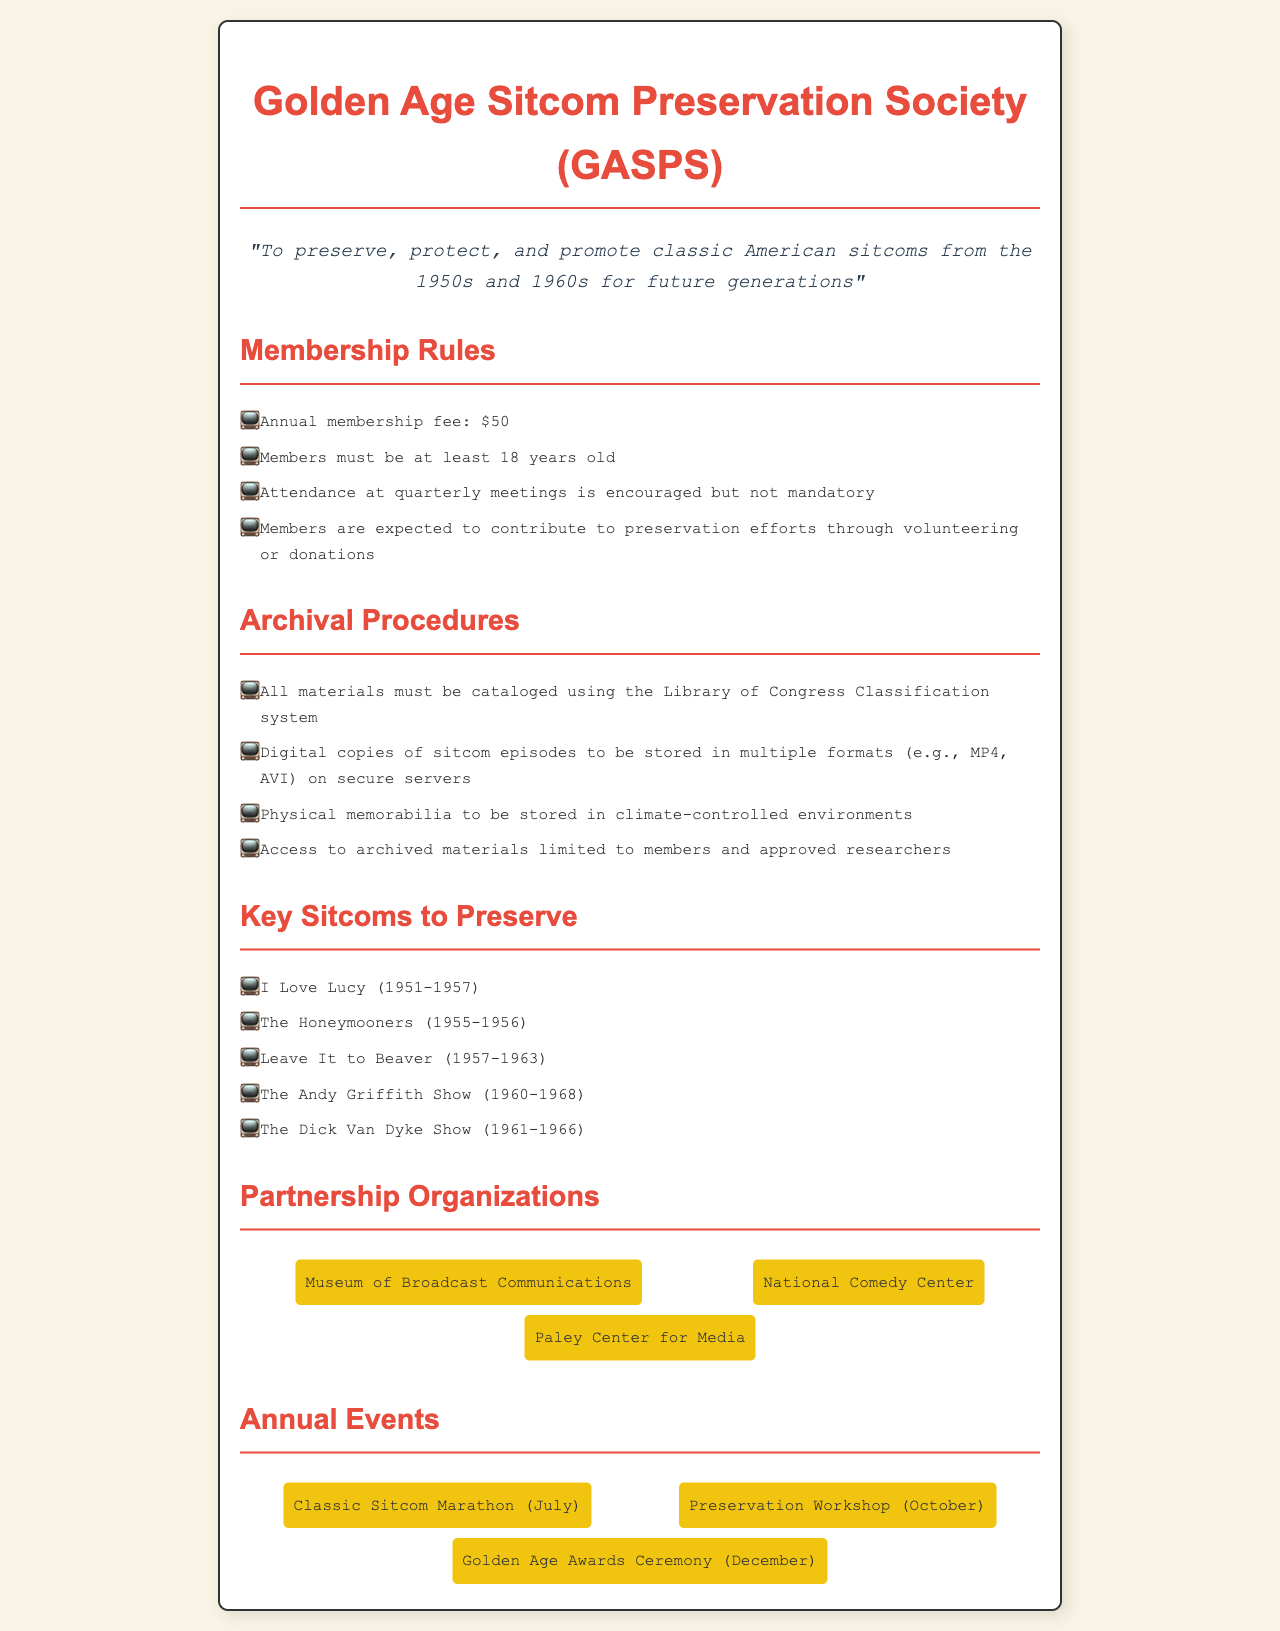What is the annual membership fee? The document states that the annual membership fee is listed under the membership rules.
Answer: $50 How old must members be? The minimum age requirement for members is mentioned in the membership rules section.
Answer: 18 years old What classification system is used for cataloging materials? The document specifies that materials must be cataloged using a particular classification system in the archival procedures.
Answer: Library of Congress Classification system Name one sitcom listed as key to preserve. The document provides a list of key sitcoms to preserve under a specific heading.
Answer: I Love Lucy What event occurs in July? The document outlines annual events, one of which takes place in July.
Answer: Classic Sitcom Marathon How often are meetings encouraged for members? The membership rules section indicates the frequency of meetings encouraged for members.
Answer: Quarterly Which organization partners with GASPS? The document mentions several organizations but specifically lists partnerships in a dedicated section.
Answer: Museum of Broadcast Communications What is expected of members regarding preservation efforts? The membership rules section specifies contributions expected from members for preservation efforts.
Answer: Volunteering or donations How are physical memorabilia stored? The archival procedures outline the storage requirements for physical memorabilia.
Answer: Climate-controlled environments 